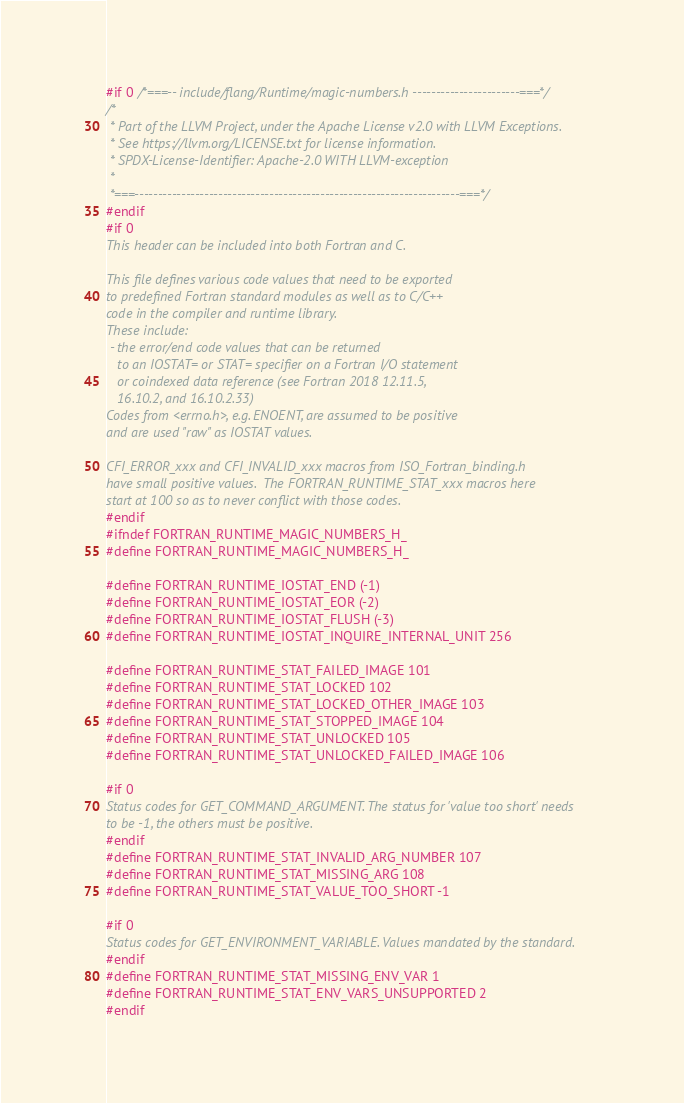<code> <loc_0><loc_0><loc_500><loc_500><_C_>#if 0 /*===-- include/flang/Runtime/magic-numbers.h -----------------------===*/
/*
 * Part of the LLVM Project, under the Apache License v2.0 with LLVM Exceptions.
 * See https://llvm.org/LICENSE.txt for license information.
 * SPDX-License-Identifier: Apache-2.0 WITH LLVM-exception
 *
 *===----------------------------------------------------------------------===*/
#endif
#if 0
This header can be included into both Fortran and C.

This file defines various code values that need to be exported
to predefined Fortran standard modules as well as to C/C++
code in the compiler and runtime library.
These include:
 - the error/end code values that can be returned
   to an IOSTAT= or STAT= specifier on a Fortran I/O statement
   or coindexed data reference (see Fortran 2018 12.11.5,
   16.10.2, and 16.10.2.33)
Codes from <errno.h>, e.g. ENOENT, are assumed to be positive
and are used "raw" as IOSTAT values.

CFI_ERROR_xxx and CFI_INVALID_xxx macros from ISO_Fortran_binding.h
have small positive values.  The FORTRAN_RUNTIME_STAT_xxx macros here
start at 100 so as to never conflict with those codes.
#endif
#ifndef FORTRAN_RUNTIME_MAGIC_NUMBERS_H_
#define FORTRAN_RUNTIME_MAGIC_NUMBERS_H_

#define FORTRAN_RUNTIME_IOSTAT_END (-1)
#define FORTRAN_RUNTIME_IOSTAT_EOR (-2)
#define FORTRAN_RUNTIME_IOSTAT_FLUSH (-3)
#define FORTRAN_RUNTIME_IOSTAT_INQUIRE_INTERNAL_UNIT 256

#define FORTRAN_RUNTIME_STAT_FAILED_IMAGE 101
#define FORTRAN_RUNTIME_STAT_LOCKED 102
#define FORTRAN_RUNTIME_STAT_LOCKED_OTHER_IMAGE 103
#define FORTRAN_RUNTIME_STAT_STOPPED_IMAGE 104
#define FORTRAN_RUNTIME_STAT_UNLOCKED 105
#define FORTRAN_RUNTIME_STAT_UNLOCKED_FAILED_IMAGE 106

#if 0
Status codes for GET_COMMAND_ARGUMENT. The status for 'value too short' needs
to be -1, the others must be positive.
#endif
#define FORTRAN_RUNTIME_STAT_INVALID_ARG_NUMBER 107
#define FORTRAN_RUNTIME_STAT_MISSING_ARG 108
#define FORTRAN_RUNTIME_STAT_VALUE_TOO_SHORT -1

#if 0
Status codes for GET_ENVIRONMENT_VARIABLE. Values mandated by the standard.
#endif
#define FORTRAN_RUNTIME_STAT_MISSING_ENV_VAR 1
#define FORTRAN_RUNTIME_STAT_ENV_VARS_UNSUPPORTED 2
#endif
</code> 